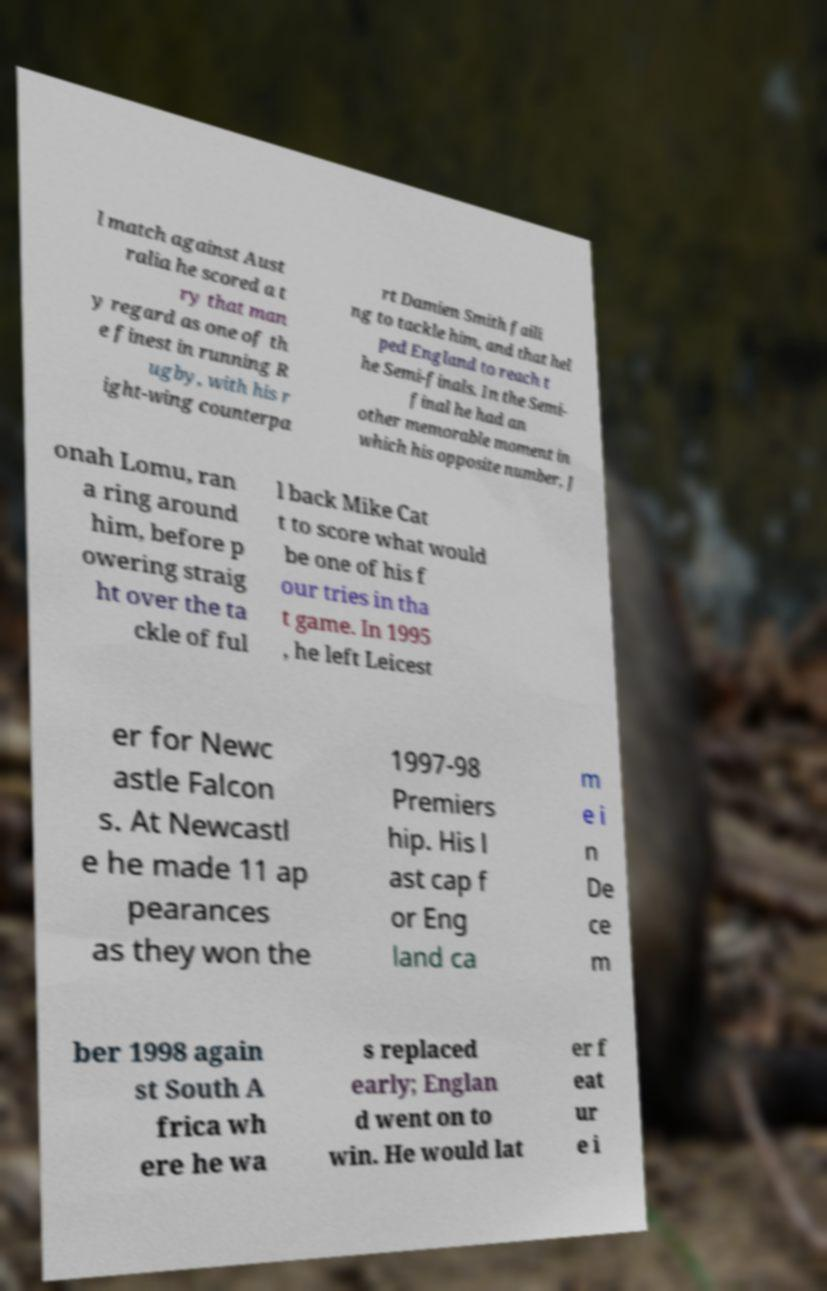Can you accurately transcribe the text from the provided image for me? l match against Aust ralia he scored a t ry that man y regard as one of th e finest in running R ugby, with his r ight-wing counterpa rt Damien Smith faili ng to tackle him, and that hel ped England to reach t he Semi-finals. In the Semi- final he had an other memorable moment in which his opposite number, J onah Lomu, ran a ring around him, before p owering straig ht over the ta ckle of ful l back Mike Cat t to score what would be one of his f our tries in tha t game. In 1995 , he left Leicest er for Newc astle Falcon s. At Newcastl e he made 11 ap pearances as they won the 1997-98 Premiers hip. His l ast cap f or Eng land ca m e i n De ce m ber 1998 again st South A frica wh ere he wa s replaced early; Englan d went on to win. He would lat er f eat ur e i 